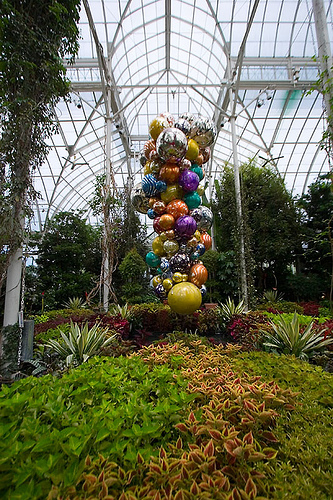<image>
Can you confirm if the balloons is behind the tree? No. The balloons is not behind the tree. From this viewpoint, the balloons appears to be positioned elsewhere in the scene. Is the balloon in front of the tree? Yes. The balloon is positioned in front of the tree, appearing closer to the camera viewpoint. 